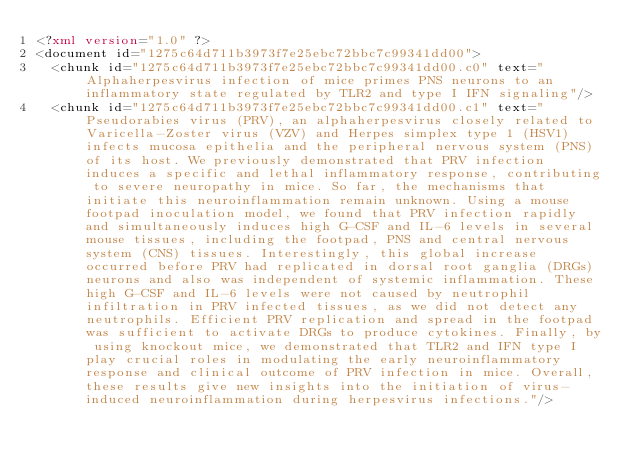<code> <loc_0><loc_0><loc_500><loc_500><_XML_><?xml version="1.0" ?>
<document id="1275c64d711b3973f7e25ebc72bbc7c99341dd00">
  <chunk id="1275c64d711b3973f7e25ebc72bbc7c99341dd00.c0" text="Alphaherpesvirus infection of mice primes PNS neurons to an inflammatory state regulated by TLR2 and type I IFN signaling"/>
  <chunk id="1275c64d711b3973f7e25ebc72bbc7c99341dd00.c1" text="Pseudorabies virus (PRV), an alphaherpesvirus closely related to Varicella-Zoster virus (VZV) and Herpes simplex type 1 (HSV1) infects mucosa epithelia and the peripheral nervous system (PNS) of its host. We previously demonstrated that PRV infection induces a specific and lethal inflammatory response, contributing to severe neuropathy in mice. So far, the mechanisms that initiate this neuroinflammation remain unknown. Using a mouse footpad inoculation model, we found that PRV infection rapidly and simultaneously induces high G-CSF and IL-6 levels in several mouse tissues, including the footpad, PNS and central nervous system (CNS) tissues. Interestingly, this global increase occurred before PRV had replicated in dorsal root ganglia (DRGs) neurons and also was independent of systemic inflammation. These high G-CSF and IL-6 levels were not caused by neutrophil infiltration in PRV infected tissues, as we did not detect any neutrophils. Efficient PRV replication and spread in the footpad was sufficient to activate DRGs to produce cytokines. Finally, by using knockout mice, we demonstrated that TLR2 and IFN type I play crucial roles in modulating the early neuroinflammatory response and clinical outcome of PRV infection in mice. Overall, these results give new insights into the initiation of virus-induced neuroinflammation during herpesvirus infections."/></code> 